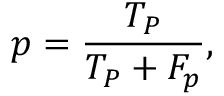<formula> <loc_0><loc_0><loc_500><loc_500>p = \frac { T _ { P } } { T _ { P } + F _ { p } } ,</formula> 